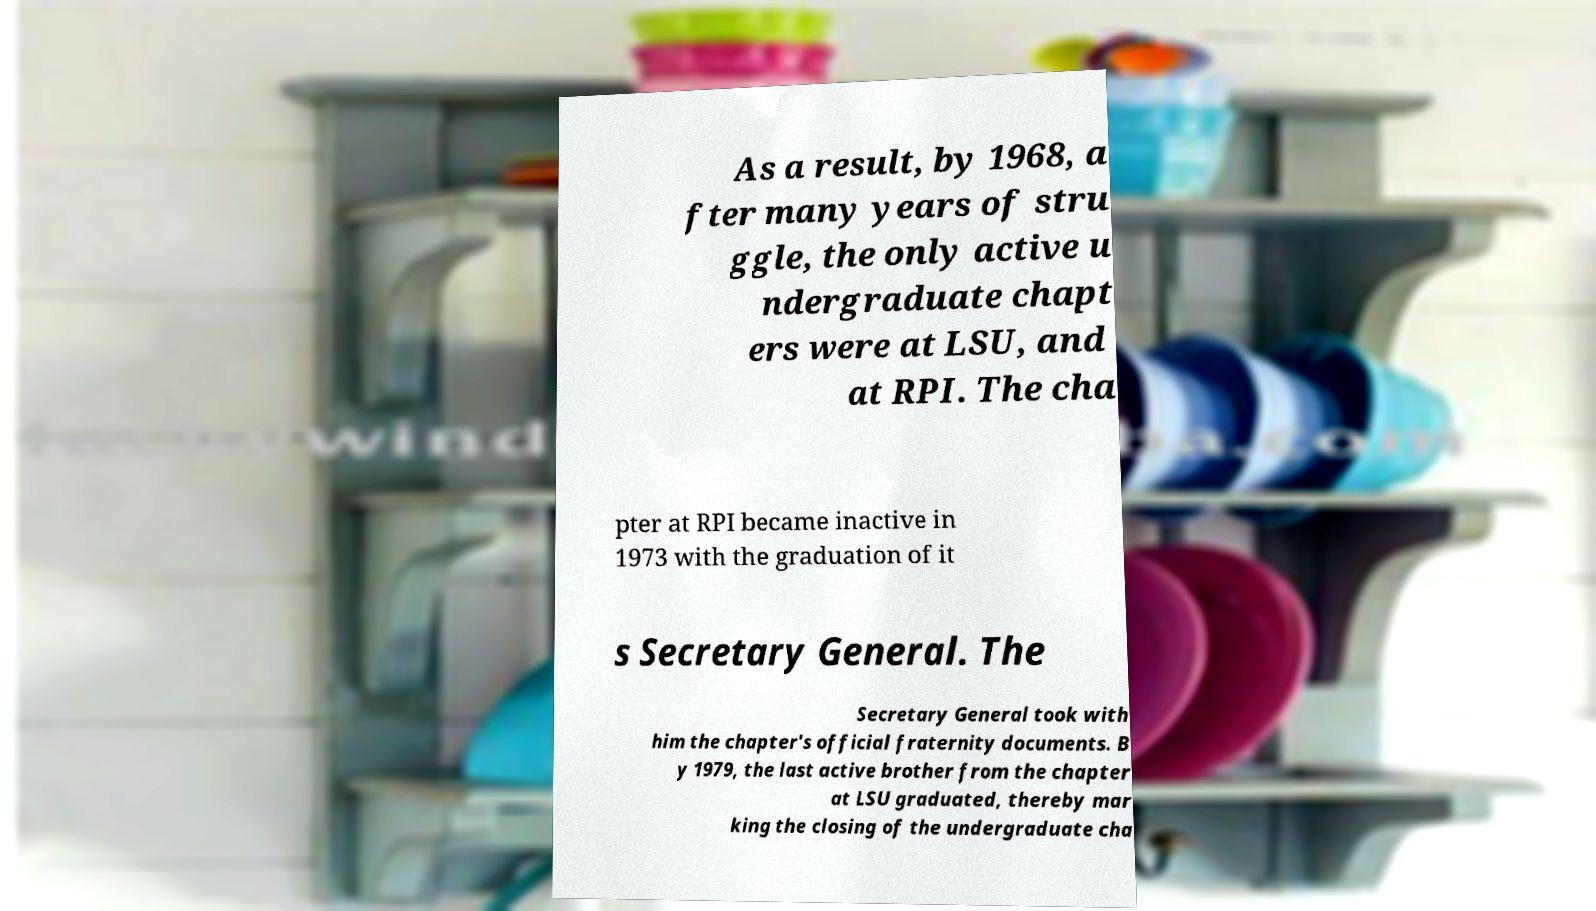Could you extract and type out the text from this image? As a result, by 1968, a fter many years of stru ggle, the only active u ndergraduate chapt ers were at LSU, and at RPI. The cha pter at RPI became inactive in 1973 with the graduation of it s Secretary General. The Secretary General took with him the chapter's official fraternity documents. B y 1979, the last active brother from the chapter at LSU graduated, thereby mar king the closing of the undergraduate cha 